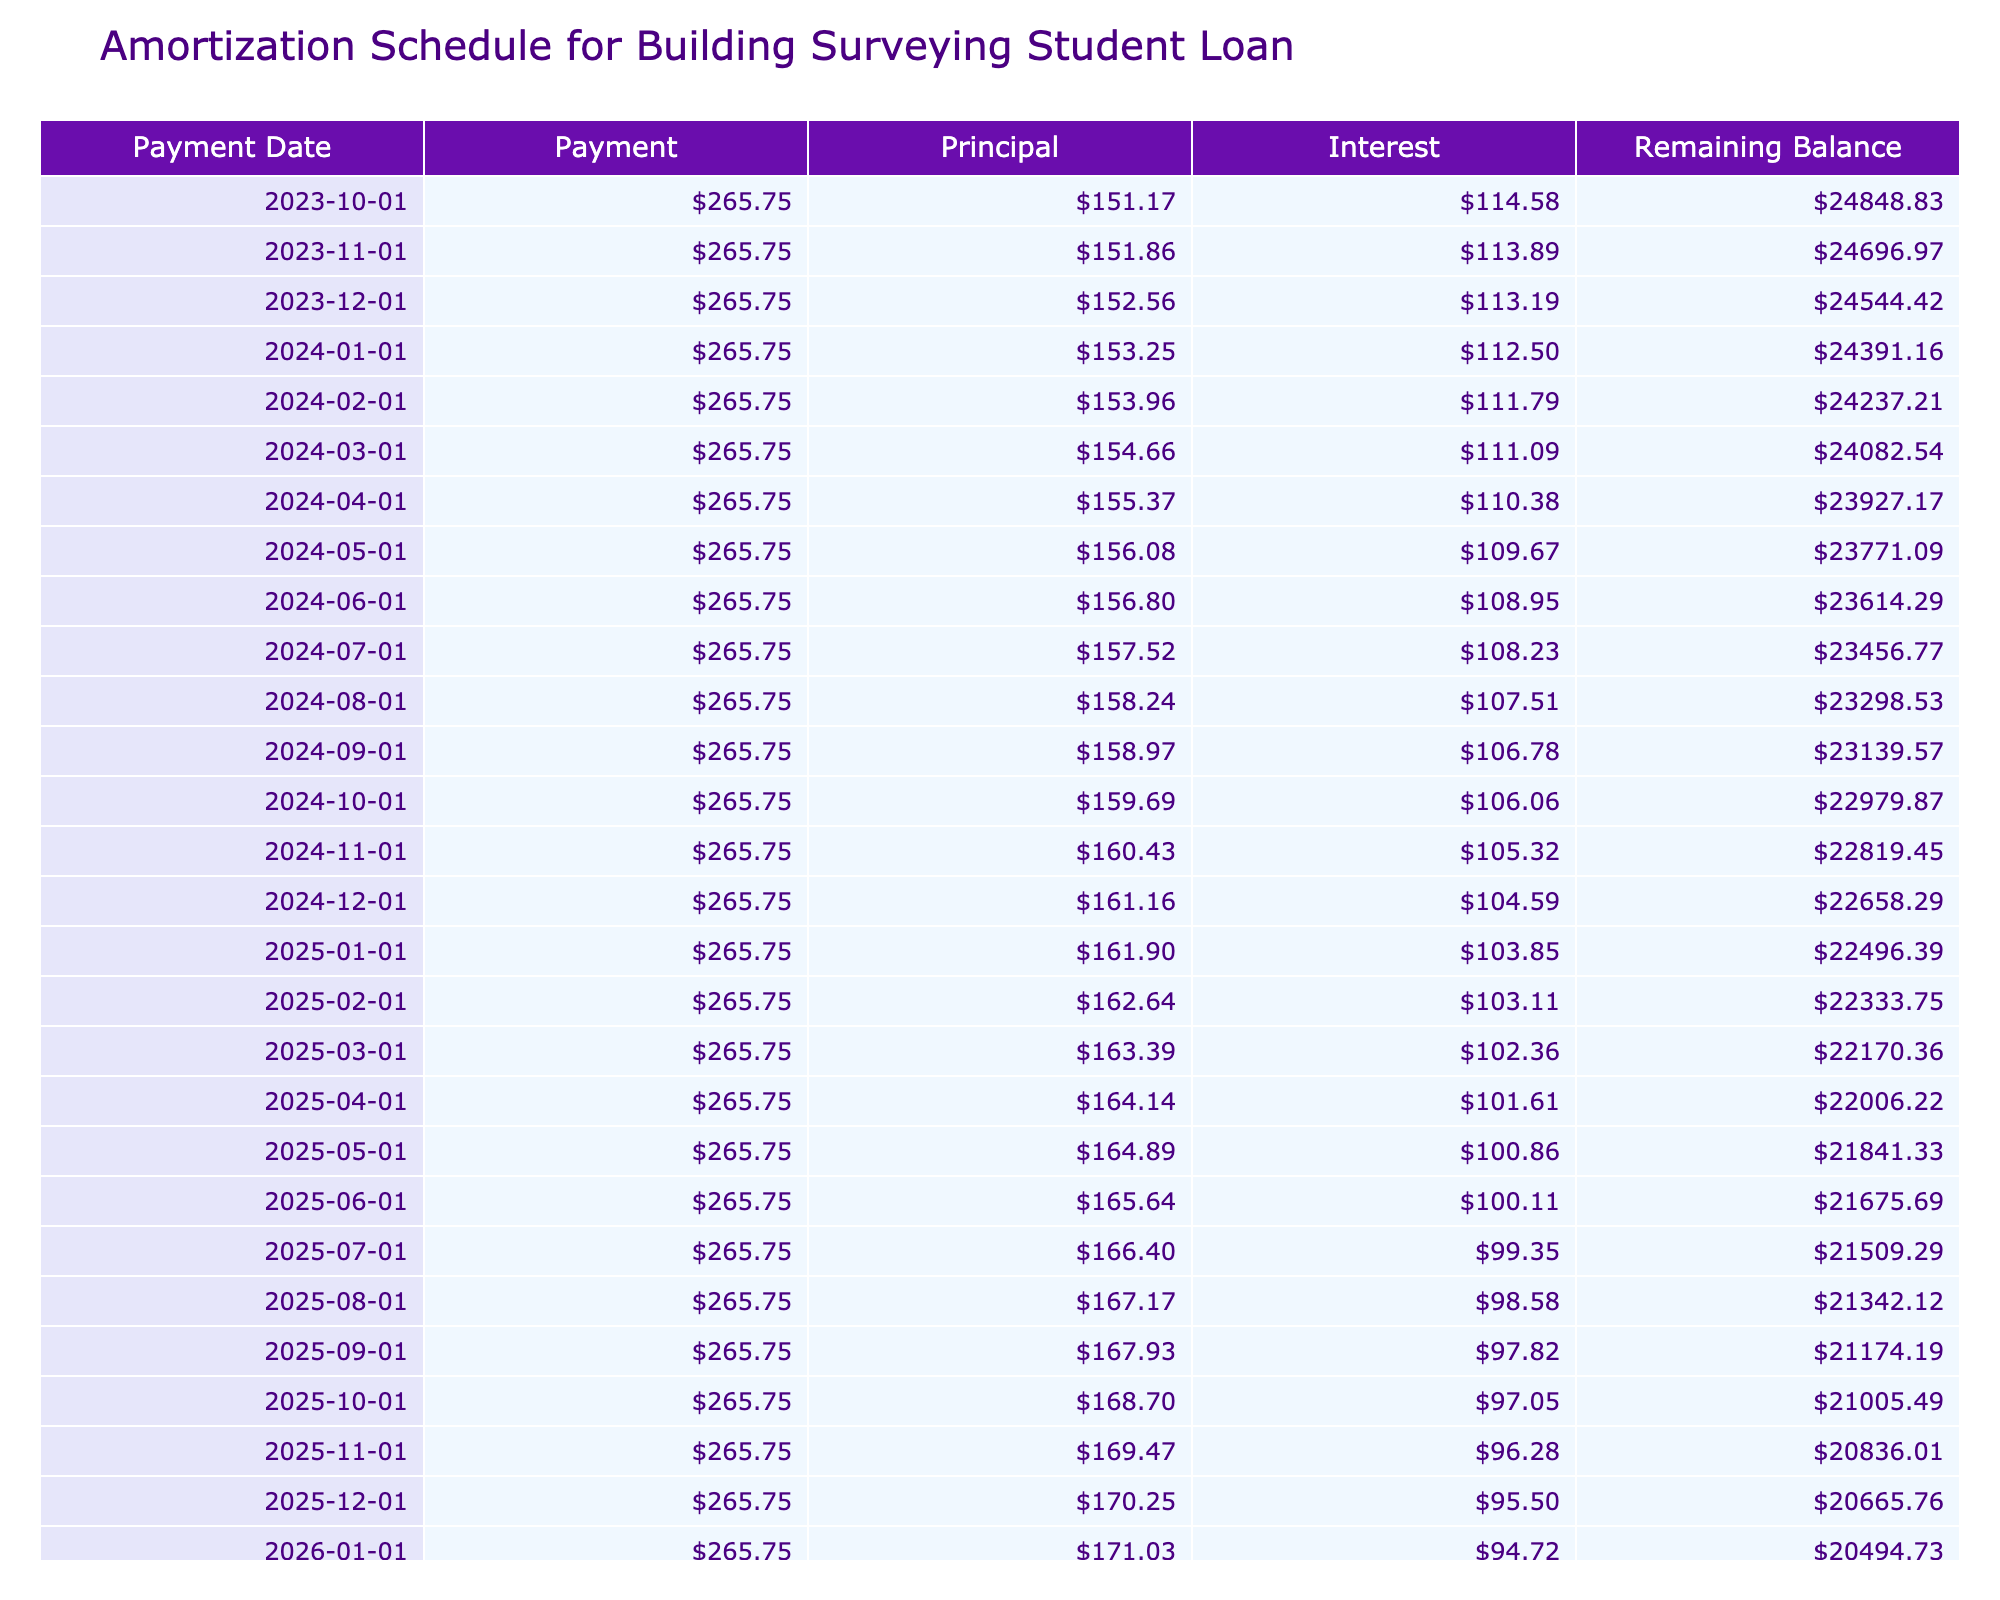What is the loan amount for the Building Surveying degree? The table states the loan amount in the first column. It shows $25,000 as the amount borrowed.
Answer: $25,000 What is the total interest paid over the duration of the loan? The total interest paid is located in the last column of the table, which indicates $6,901.44 as the total interest accrued by the end of the loan term.
Answer: $6,901.44 What is the monthly payment amount? The monthly payment is shown in the table under the 'Payment' column, which lists the value as $265.75 that will be paid each month.
Answer: $265.75 Is the annual interest rate more than 5%? The annual interest rate given in the table is 5.5%, which is indeed greater than 5%.
Answer: Yes What will be the remaining balance after the first payment? To find the remaining balance after the first payment, we can use the initial loan amount and subtract the principal portion of the first payment. The balance is $25,000 - (Monthly Payment - (Loan Amount * Monthly Rate)) = $25,000 - (265.75 - (25000 * 0.004583)) = $24,714.69.
Answer: $24,714.69 How much interest is paid in the last month of the loan? The last row indicates the last payment date, and we can refer to the 'Interest' column of that row, which shows that the interest paid in the final month amounts to $1.38.
Answer: $1.38 What is the total amount paid by the end of the loan term? The total paid at the end of the loan term is provided in the last column as $31,901.44, which sums both the principal and the total interest paid over 10 years.
Answer: $31,901.44 What is the average monthly payment throughout the loan term? Since the monthly payment is the same every month for the entire loan, the average monthly payment is equal to the monthly payment itself, which is $265.75.
Answer: $265.75 Is the total paid by the borrower more than 30,000? The total paid is $31,901.44, which is indeed more than $30,000, confirming the statement as true.
Answer: Yes 